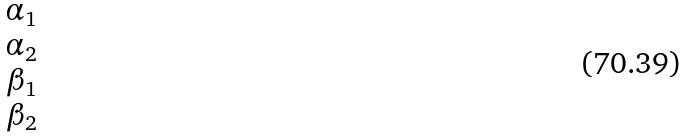Convert formula to latex. <formula><loc_0><loc_0><loc_500><loc_500>\begin{matrix} \alpha _ { 1 } \\ \alpha _ { 2 } \\ \beta _ { 1 } \\ \beta _ { 2 } \\ \end{matrix}</formula> 